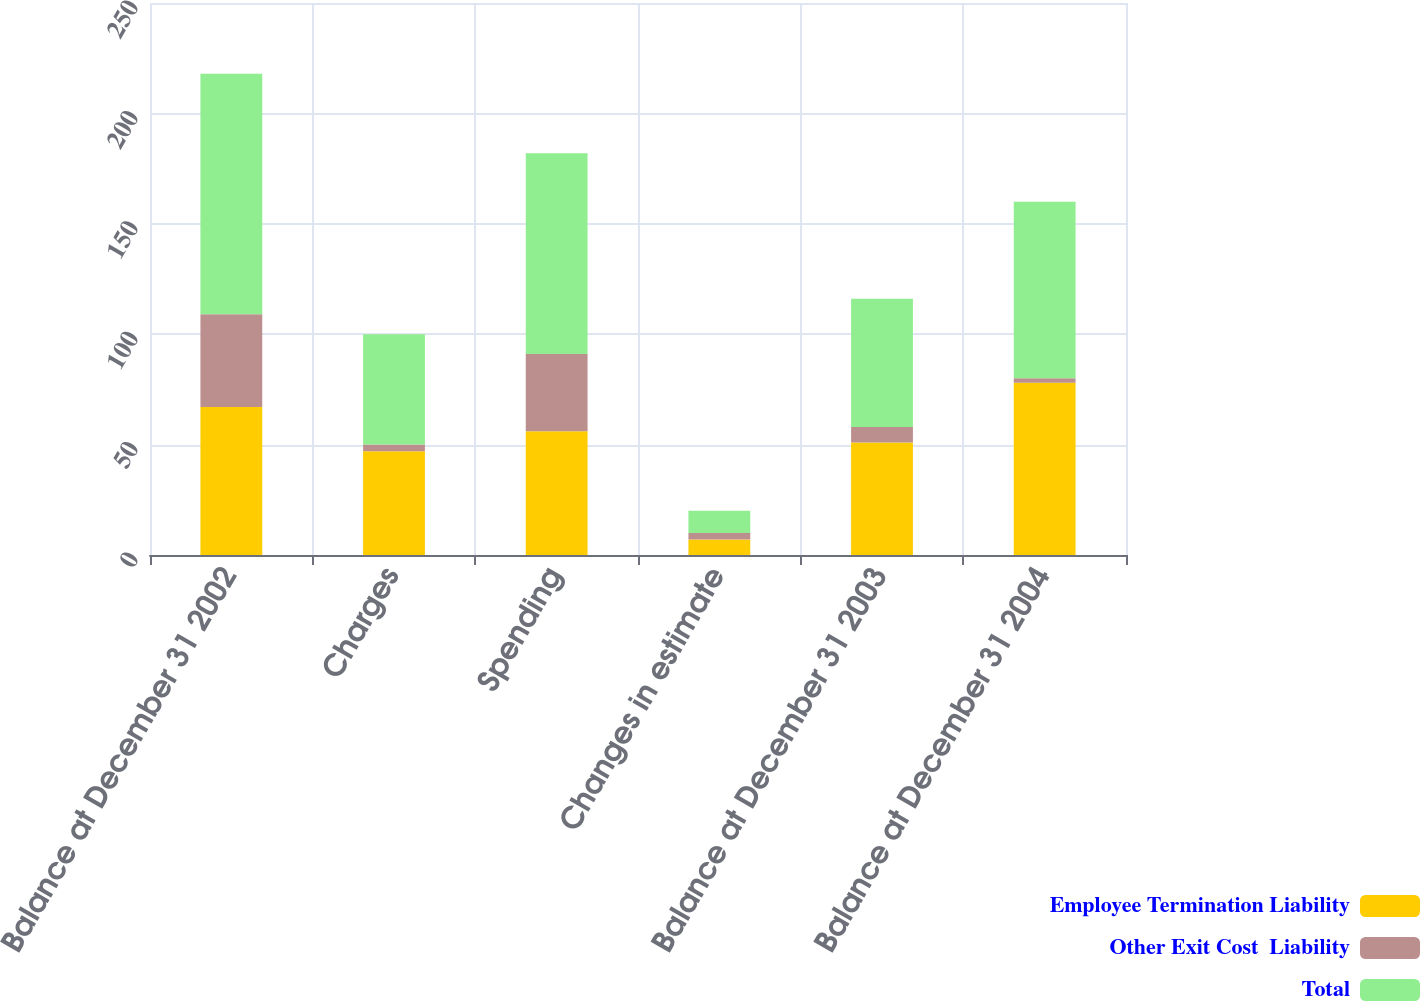<chart> <loc_0><loc_0><loc_500><loc_500><stacked_bar_chart><ecel><fcel>Balance at December 31 2002<fcel>Charges<fcel>Spending<fcel>Changes in estimate<fcel>Balance at December 31 2003<fcel>Balance at December 31 2004<nl><fcel>Employee Termination Liability<fcel>67<fcel>47<fcel>56<fcel>7<fcel>51<fcel>78<nl><fcel>Other Exit Cost  Liability<fcel>42<fcel>3<fcel>35<fcel>3<fcel>7<fcel>2<nl><fcel>Total<fcel>109<fcel>50<fcel>91<fcel>10<fcel>58<fcel>80<nl></chart> 